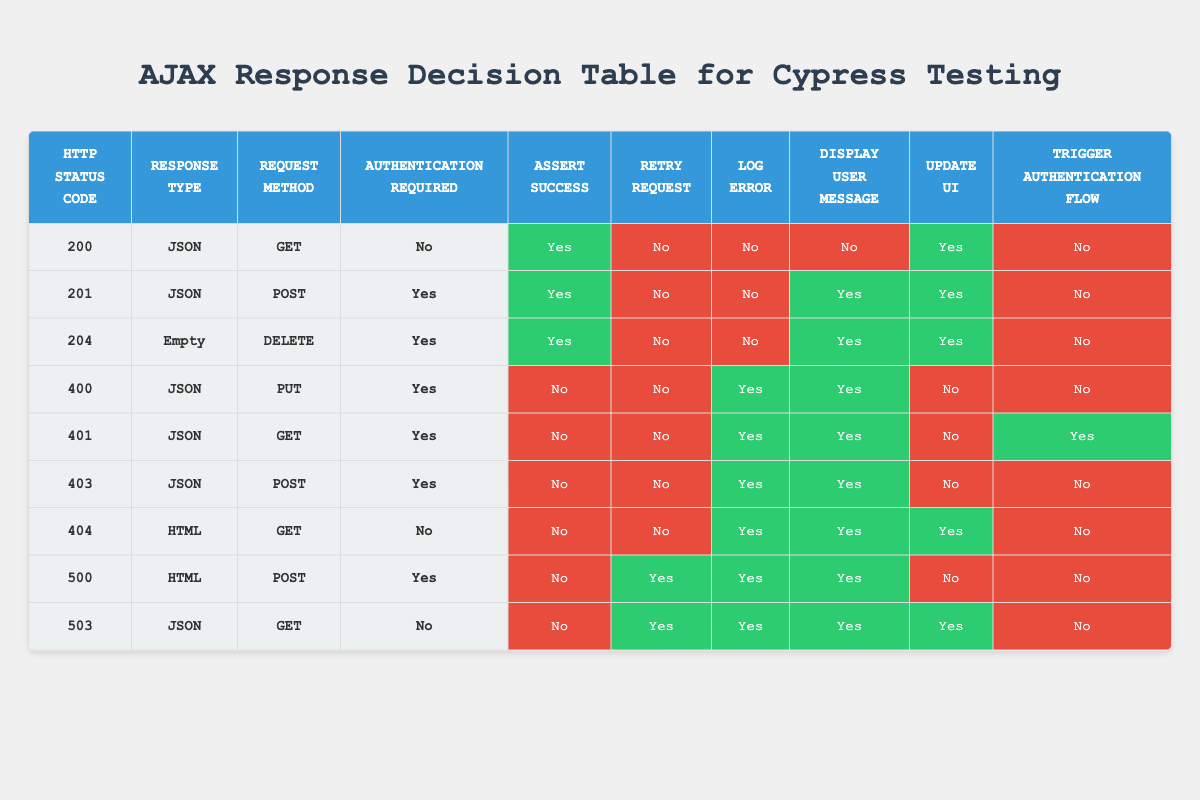What actions are taken for an HTTP status code of 200? For the HTTP status code 200, the table shows the actions to be taken: Assert Success is "Yes," Retry Request is "No," Log Error is "No," Display User Message is "No," Update UI is "Yes," and Trigger Authentication Flow is "No." Therefore, the actions are mostly positive with respect to success and updating the UI.
Answer: Assert Success: Yes, Update UI: Yes What HTTP status codes result in a prompt for user authentication? The status codes indicating that authentication is required are 401 and 403. For both, 'Trigger Authentication Flow' is "Yes". Thus, any response with these codes will ask for user authentication.
Answer: 401, 403 How many total actions are taken when the HTTP status code is 404? The relevant actions for HTTP status code 404 include Log Error: "Yes," Display User Message: "Yes," Update UI: "Yes." This counts as three actions that are taken when this status code is encountered.
Answer: 3 Is it necessary to retry the request for an HTTP status code of 500? The table indicates that for status code 500, Retry Request is "Yes." Thus, it is necessary to retry the request when encountering this status code.
Answer: Yes What is the difference in action between a 204 and a 400 status code in terms of logging errors? For status code 204, Log Error is "No," while for status code 400, Log Error is "Yes." Therefore, the difference is that for a 204 response, no errors are logged, whereas for a 400, errors are logged.
Answer: 1 (logs for 400, none for 204) How many unique combinations of Response Type and Request Method correspond to the HTTP status code of 503? The HTTP status code 503 has only one unique combination: Response Type is JSON and Request Method is GET. Therefore, there is one unique combination corresponding to it.
Answer: 1 What happens when the response is a 500 status code regarding user message display? The table shows that when the response is a 500 status code, Display User Message is "Yes." This means that a message will be displayed to the user regarding the error.
Answer: Yes For which status codes does the UI get updated? The status codes that result in an update to the UI are 200, 201, 204, 404, and 503. In total, there are five status codes where the UI will be updated according to the table.
Answer: 5 